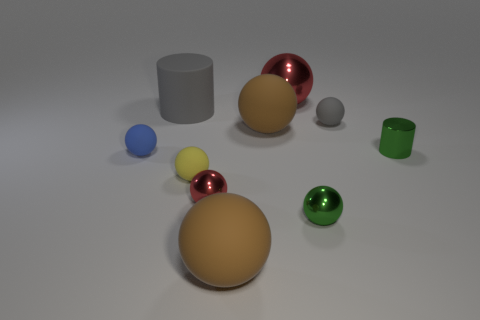Subtract all green spheres. How many spheres are left? 7 Subtract all yellow spheres. How many spheres are left? 7 Subtract all purple balls. Subtract all blue cylinders. How many balls are left? 8 Subtract all spheres. How many objects are left? 2 Add 9 gray rubber balls. How many gray rubber balls are left? 10 Add 6 yellow matte blocks. How many yellow matte blocks exist? 6 Subtract 0 purple blocks. How many objects are left? 10 Subtract all green metallic things. Subtract all green metallic cylinders. How many objects are left? 7 